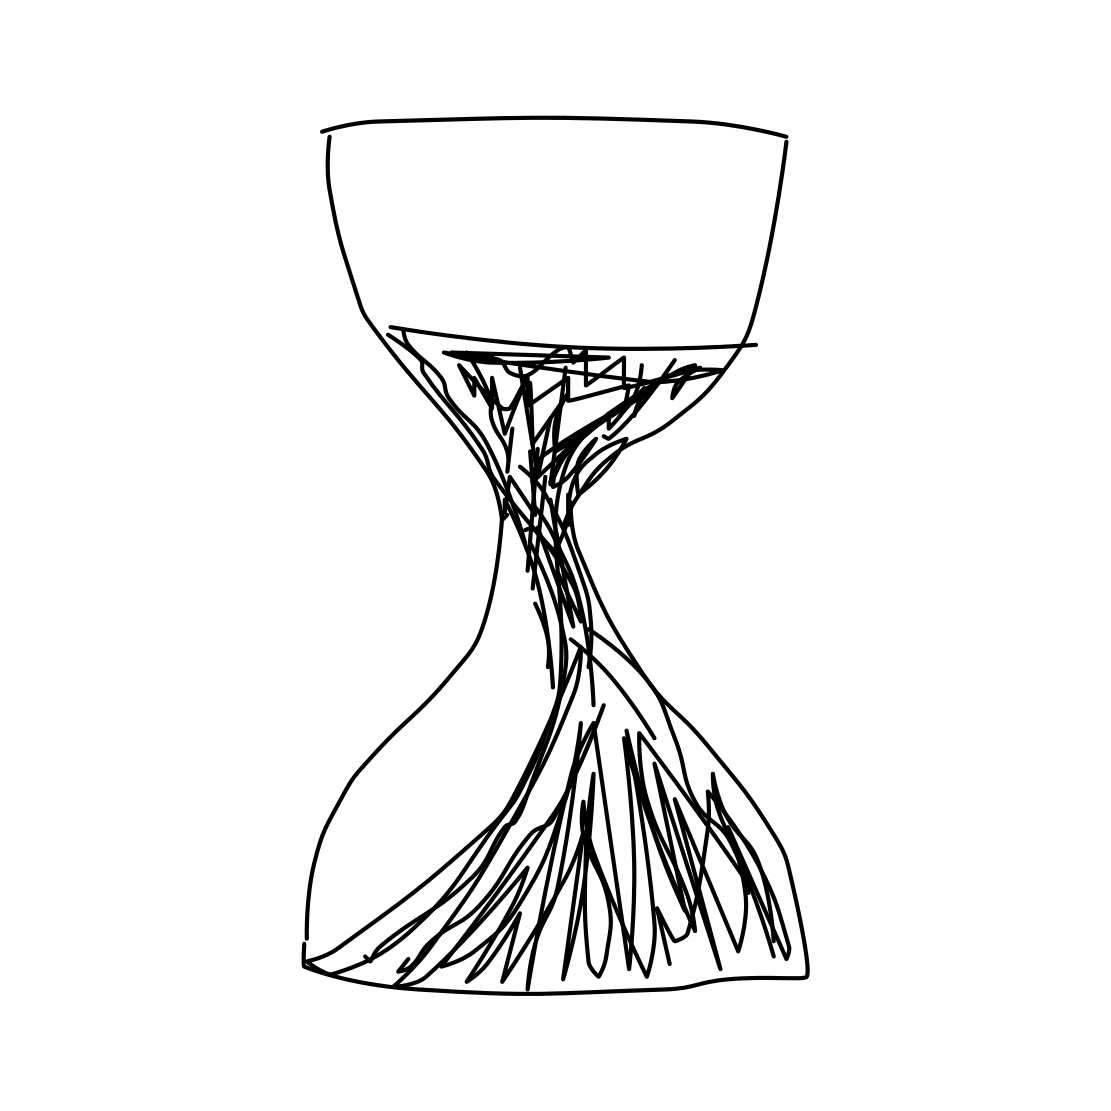What does the hourglass in the image represent? The hourglass typically symbolizes the passage of time and the finite nature of existence. In this image, the hourglass might also signify urgency or the importance of valuing the time we have. 